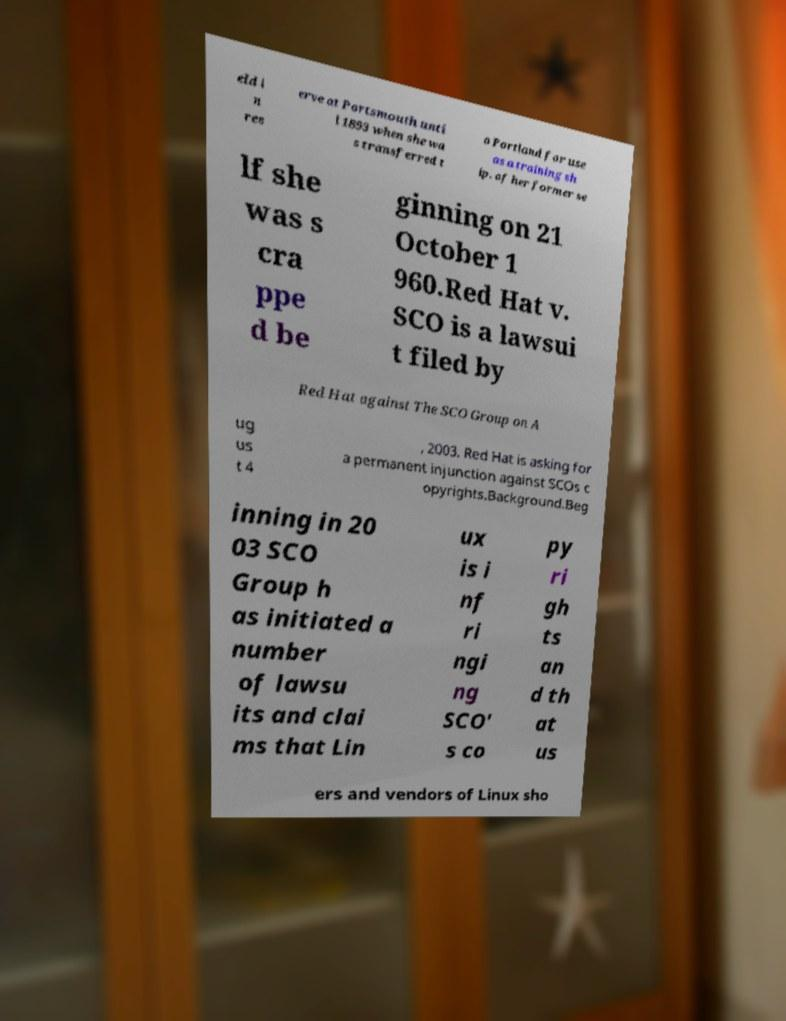Could you extract and type out the text from this image? eld i n res erve at Portsmouth unti l 1893 when she wa s transferred t o Portland for use as a training sh ip. of her former se lf she was s cra ppe d be ginning on 21 October 1 960.Red Hat v. SCO is a lawsui t filed by Red Hat against The SCO Group on A ug us t 4 , 2003. Red Hat is asking for a permanent injunction against SCOs c opyrights.Background.Beg inning in 20 03 SCO Group h as initiated a number of lawsu its and clai ms that Lin ux is i nf ri ngi ng SCO' s co py ri gh ts an d th at us ers and vendors of Linux sho 